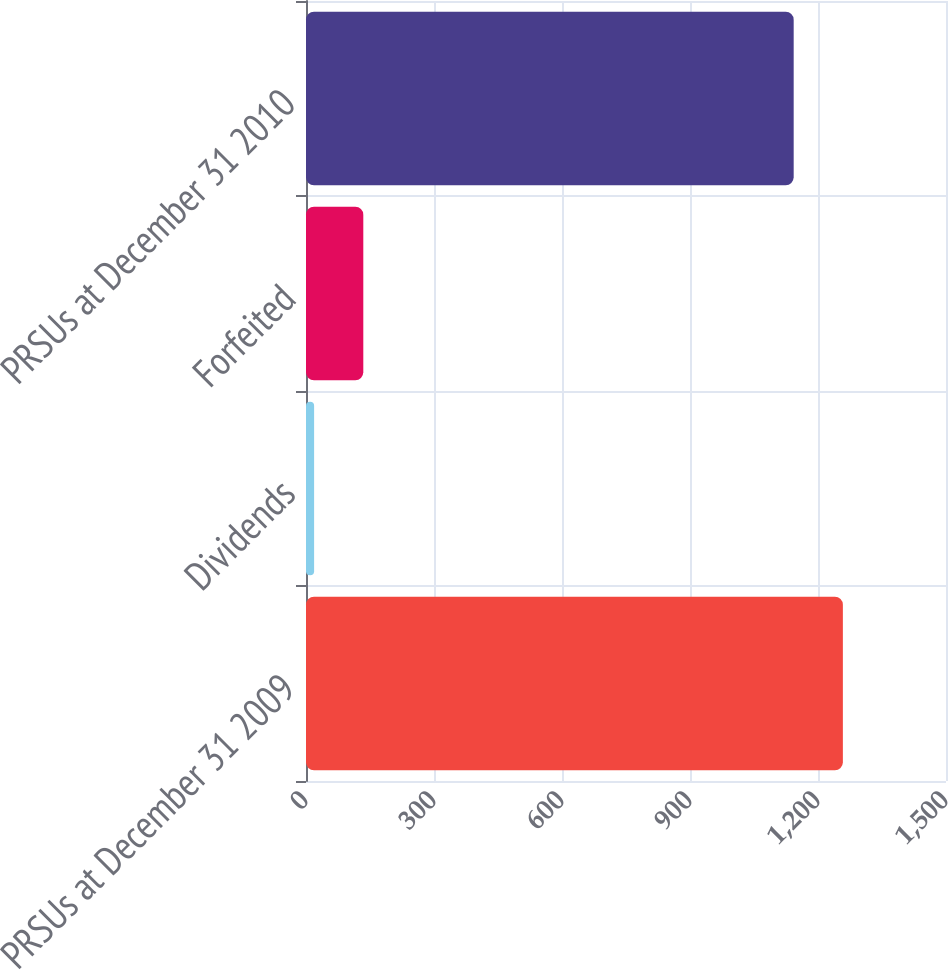<chart> <loc_0><loc_0><loc_500><loc_500><bar_chart><fcel>PRSUs at December 31 2009<fcel>Dividends<fcel>Forfeited<fcel>PRSUs at December 31 2010<nl><fcel>1258.3<fcel>19<fcel>134.3<fcel>1143<nl></chart> 